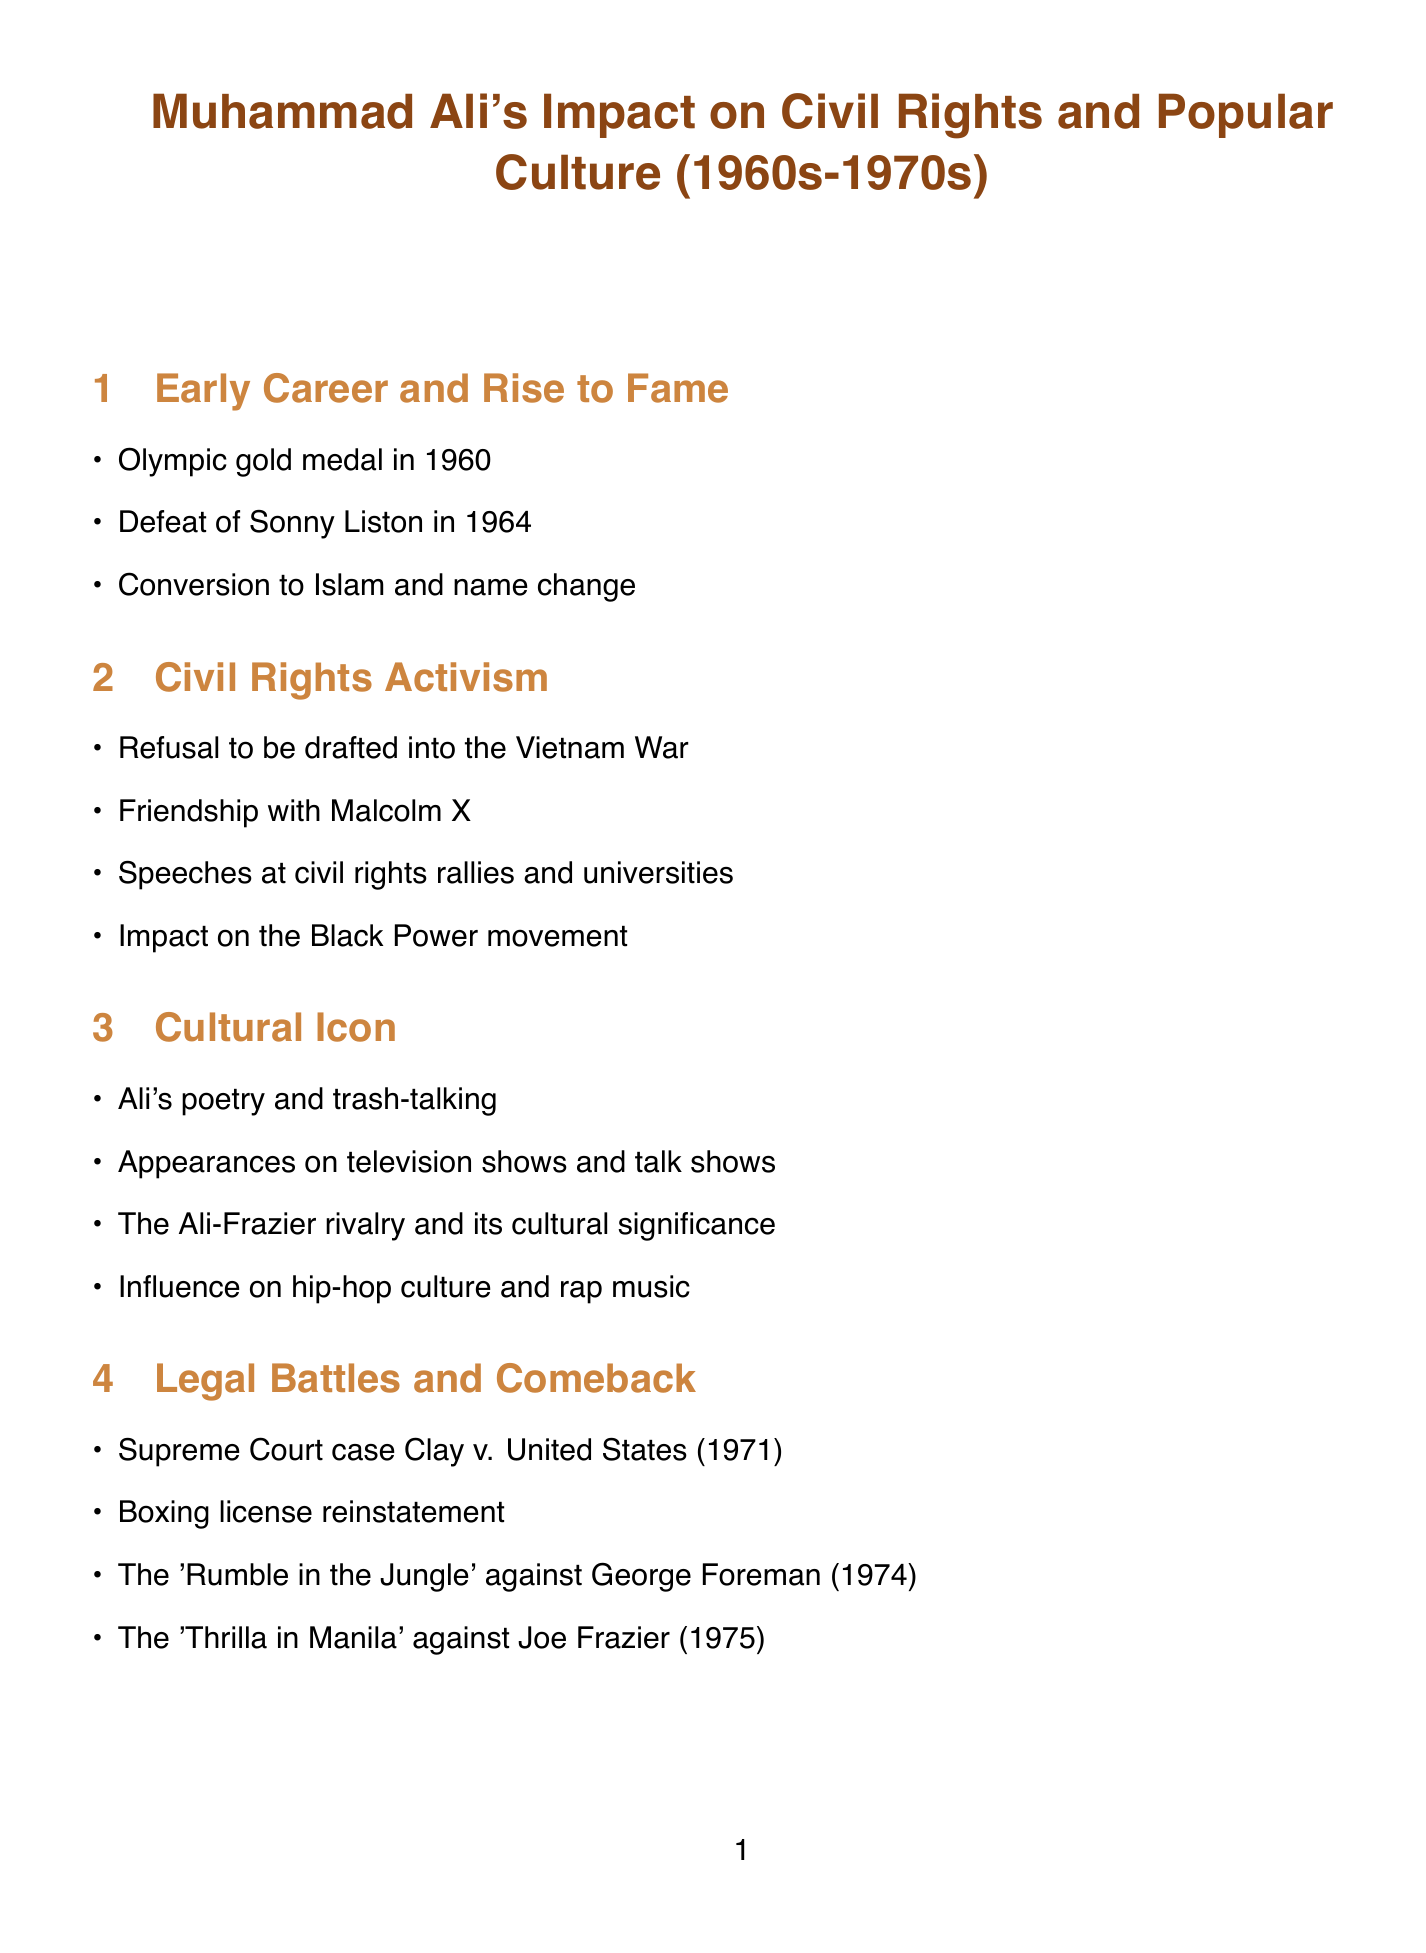What year did Muhammad Ali win an Olympic gold medal? The document states that Muhammad Ali won the Olympic gold medal in the year 1960.
Answer: 1960 Who did Muhammad Ali defeat to win the World Heavyweight Championship? The document mentions that Muhammad Ali defeated Sonny Liston in 1964 to win the World Heavyweight Championship.
Answer: Sonny Liston What significant action did Ali take regarding the Vietnam War? According to the document, Ali refused to be drafted into the Vietnam War, which is an important aspect of his civil rights activism.
Answer: Refusal to be drafted Which rivalry is noted for its cultural significance in the document? The document highlights the Ali-Frazier rivalry, specifically noting its impact on popular culture.
Answer: Ali-Frazier rivalry What was the outcome of the Supreme Court case involving Muhammad Ali? The document indicates that the Supreme Court case Clay v. United States resulted in a favorable outcome for Ali in 1971.
Answer: Favorable outcome Which book by Thomas Hauser is recommended in the document? The document recommends "Muhammad Ali: His Life and Times" by Thomas Hauser as one of the sources for further reading.
Answer: Muhammad Ali: His Life and Times How did Ali impact African American naming practices? The document notes that Ali influenced African American naming practices, demonstrating part of his cultural impact.
Answer: Influence on naming practices What was one of Ali's contributions to civil rights? The document states that one of Ali's contributions was advocating for racial pride and self-determination.
Answer: Advocating for racial pride What year did the "Rumble in the Jungle" fight occur? The document provides that the "Rumble in the Jungle" against George Foreman took place in 1974.
Answer: 1974 